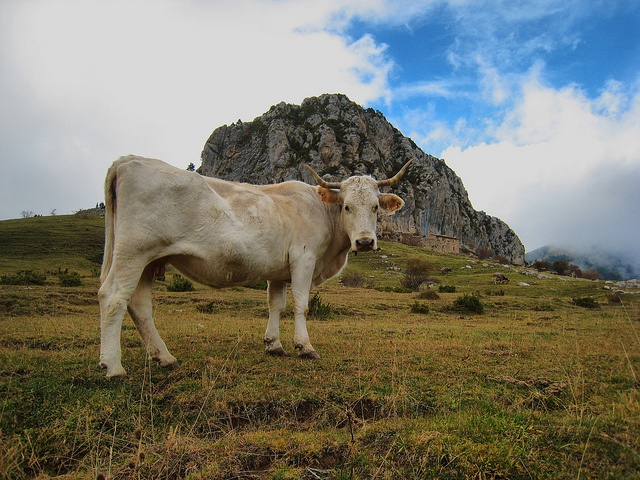Describe the objects in this image and their specific colors. I can see a cow in lightgray, gray, and darkgray tones in this image. 